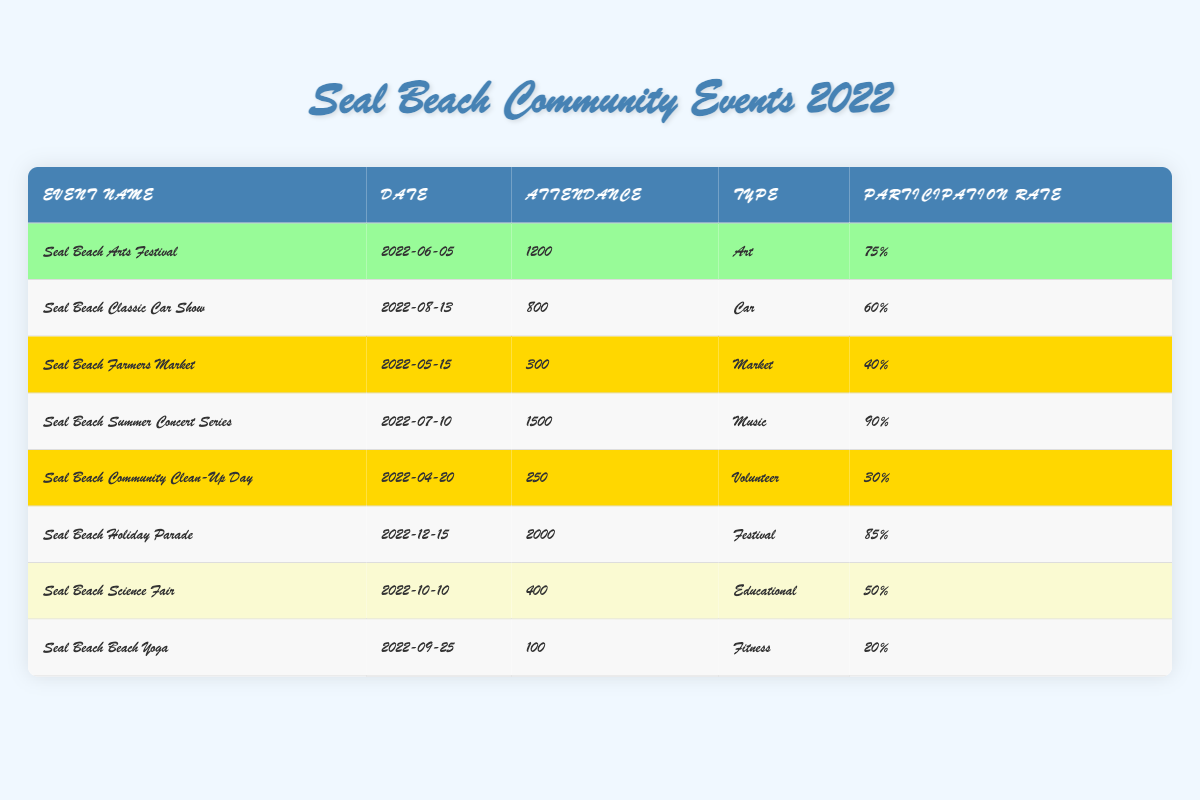What is the event with the highest attendance? The attendance numbers from the table are: 1200 for "Seal Beach Arts Festival," 800 for "Seal Beach Classic Car Show," 300 for "Seal Beach Farmers Market," 1500 for "Seal Beach Summer Concert Series," 250 for "Seal Beach Community Clean-Up Day," 2000 for "Seal Beach Holiday Parade," 400 for "Seal Beach Science Fair," and 100 for "Seal Beach Beach Yoga." The highest number is 2000 from the "Seal Beach Holiday Parade."
Answer: Seal Beach Holiday Parade Which event had the lowest participation rate? The participation rates listed in the table are: 75%, 60%, 40%, 90%, 30%, 85%, 50%, and 20%. The lowest participation rate is 20% for "Seal Beach Beach Yoga."
Answer: Seal Beach Beach Yoga How many attendees were at the Seal Beach Summer Concert Series? The table clearly states the attendance for each event; for "Seal Beach Summer Concert Series," it indicates an attendance of 1500.
Answer: 1500 What is the average participation rate for the community events listed? To find the average participation rate, we need to sum the participation rates: 75 + 60 + 40 + 90 + 30 + 85 + 50 + 20 = 450. Then we divide this sum by the number of events (8): 450 / 8 = 56.25.
Answer: 56.25% Is the participation rate of the Seal Beach Farmers Market above 50%? The participation rate for the "Seal Beach Farmers Market" is 40%. Since 40% is not above 50%, the statement is false.
Answer: No What is the total attendance for all events classified as "High" participation? The events with "High" participation are: "Seal Beach Arts Festival" (1200), "Seal Beach Summer Concert Series" (1500), and "Seal Beach Holiday Parade" (2000). Adding these together gives us 1200 + 1500 + 2000 = 4700.
Answer: 4700 Which type of event had the highest recorded attendance? The recorded attendances are 1200 for Art, 800 for Car, 300 for Market, 1500 for Music, 250 for Volunteer, 2000 for Festival, 400 for Educational, and 100 for Fitness. The highest attendance is 2000, classified as a Festival.
Answer: Festival How many events had a participation rate below 30%? The participation rates are: 75%, 60%, 40%, 90%, 30%, 85%, 50%, and 20%. Only "Seal Beach Beach Yoga" with 20% is below 30%. Therefore, there is 1 event.
Answer: 1 What is the difference in attendance between the event with the highest attendance and the one with the lowest? The highest attendance is 2000 (Seal Beach Holiday Parade) and the lowest is 100 (Seal Beach Beach Yoga). The difference is calculated as 2000 - 100 = 1900.
Answer: 1900 Which community event had a type classified as "Educational"? From the table, "Seal Beach Science Fair" is the only event classified under "Educational," and it has an attendance of 400.
Answer: Seal Beach Science Fair 